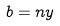<formula> <loc_0><loc_0><loc_500><loc_500>b = n y</formula> 